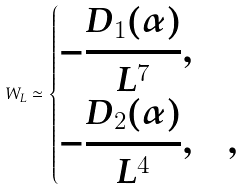Convert formula to latex. <formula><loc_0><loc_0><loc_500><loc_500>W _ { L } \simeq \begin{dcases} - \frac { D _ { 1 } ( \alpha ) } { L ^ { 7 } } , & \\ - \frac { D _ { 2 } ( \alpha ) } { L ^ { 4 } } , & , \end{dcases}</formula> 